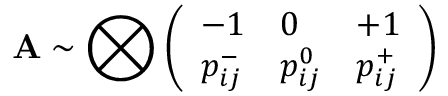<formula> <loc_0><loc_0><loc_500><loc_500>A \sim \bigotimes \left ( \begin{array} { l l l } { - 1 } & { 0 } & { + 1 } \\ { p _ { i j } ^ { - } } & { p _ { i j } ^ { 0 } } & { p _ { i j } ^ { + } } \end{array} \right )</formula> 